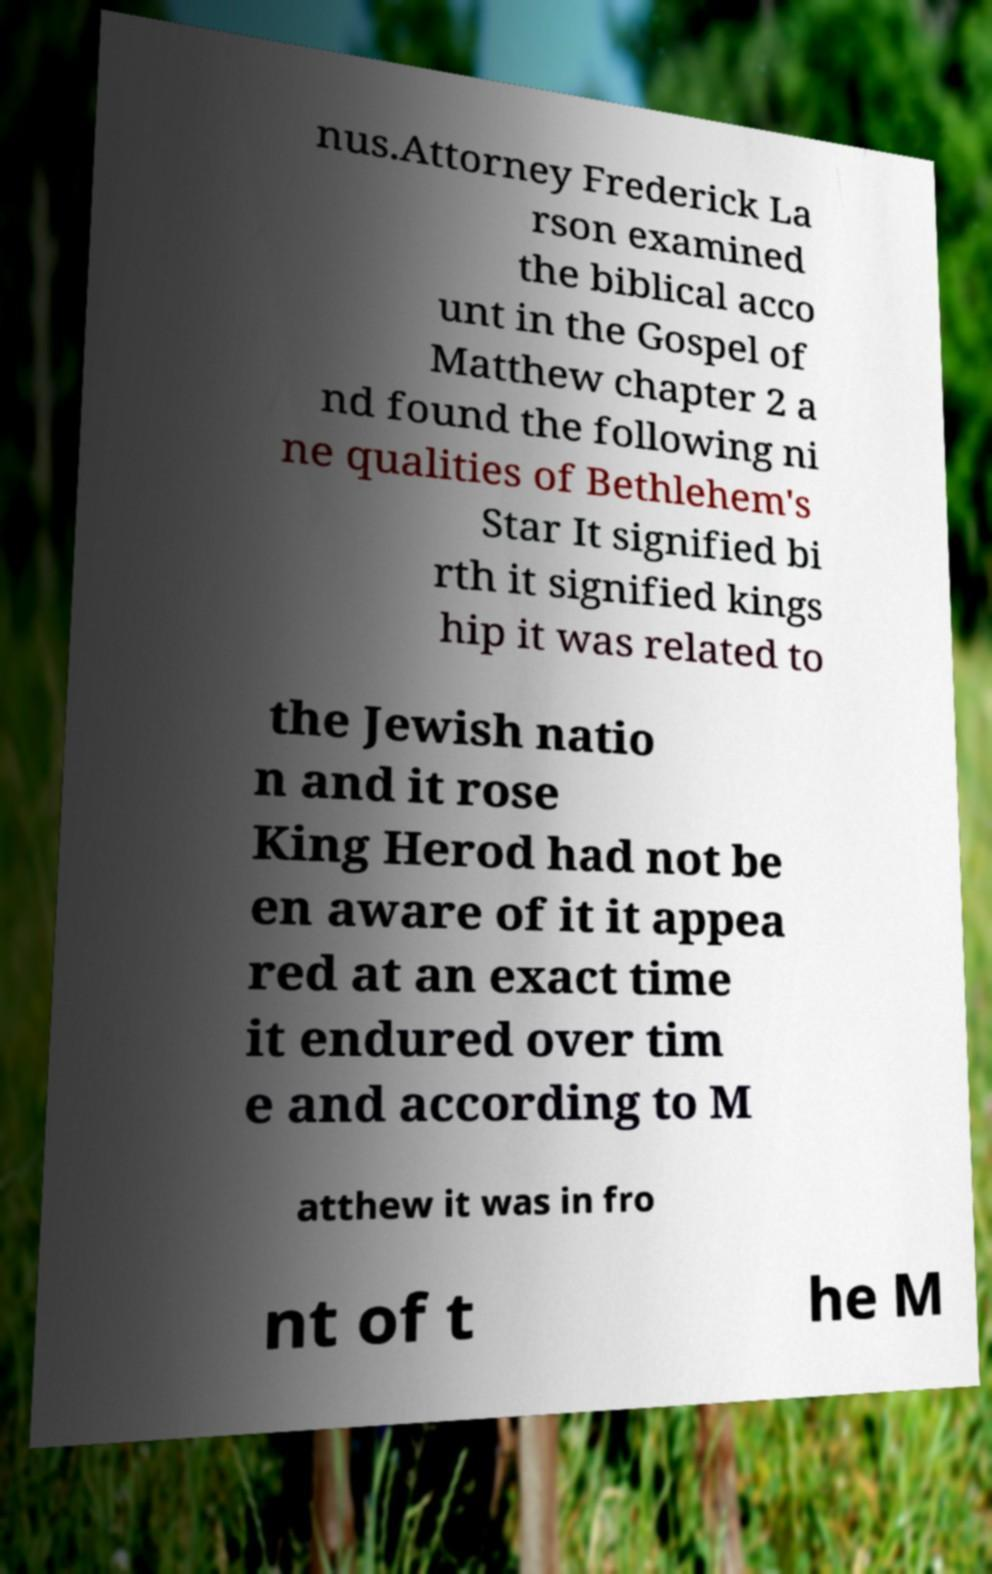Could you extract and type out the text from this image? nus.Attorney Frederick La rson examined the biblical acco unt in the Gospel of Matthew chapter 2 a nd found the following ni ne qualities of Bethlehem's Star It signified bi rth it signified kings hip it was related to the Jewish natio n and it rose King Herod had not be en aware of it it appea red at an exact time it endured over tim e and according to M atthew it was in fro nt of t he M 